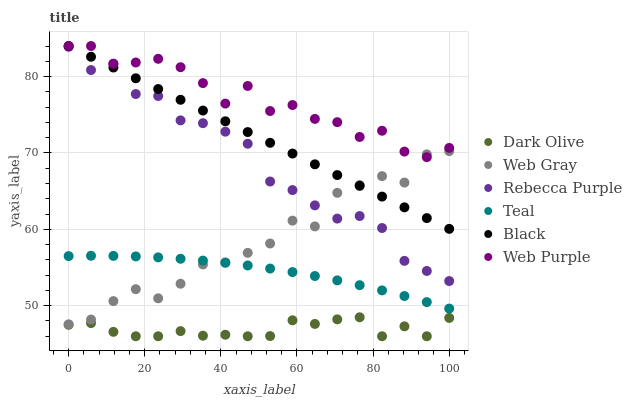Does Dark Olive have the minimum area under the curve?
Answer yes or no. Yes. Does Web Purple have the maximum area under the curve?
Answer yes or no. Yes. Does Web Purple have the minimum area under the curve?
Answer yes or no. No. Does Dark Olive have the maximum area under the curve?
Answer yes or no. No. Is Black the smoothest?
Answer yes or no. Yes. Is Web Purple the roughest?
Answer yes or no. Yes. Is Dark Olive the smoothest?
Answer yes or no. No. Is Dark Olive the roughest?
Answer yes or no. No. Does Dark Olive have the lowest value?
Answer yes or no. Yes. Does Web Purple have the lowest value?
Answer yes or no. No. Does Black have the highest value?
Answer yes or no. Yes. Does Dark Olive have the highest value?
Answer yes or no. No. Is Dark Olive less than Teal?
Answer yes or no. Yes. Is Rebecca Purple greater than Teal?
Answer yes or no. Yes. Does Web Purple intersect Black?
Answer yes or no. Yes. Is Web Purple less than Black?
Answer yes or no. No. Is Web Purple greater than Black?
Answer yes or no. No. Does Dark Olive intersect Teal?
Answer yes or no. No. 